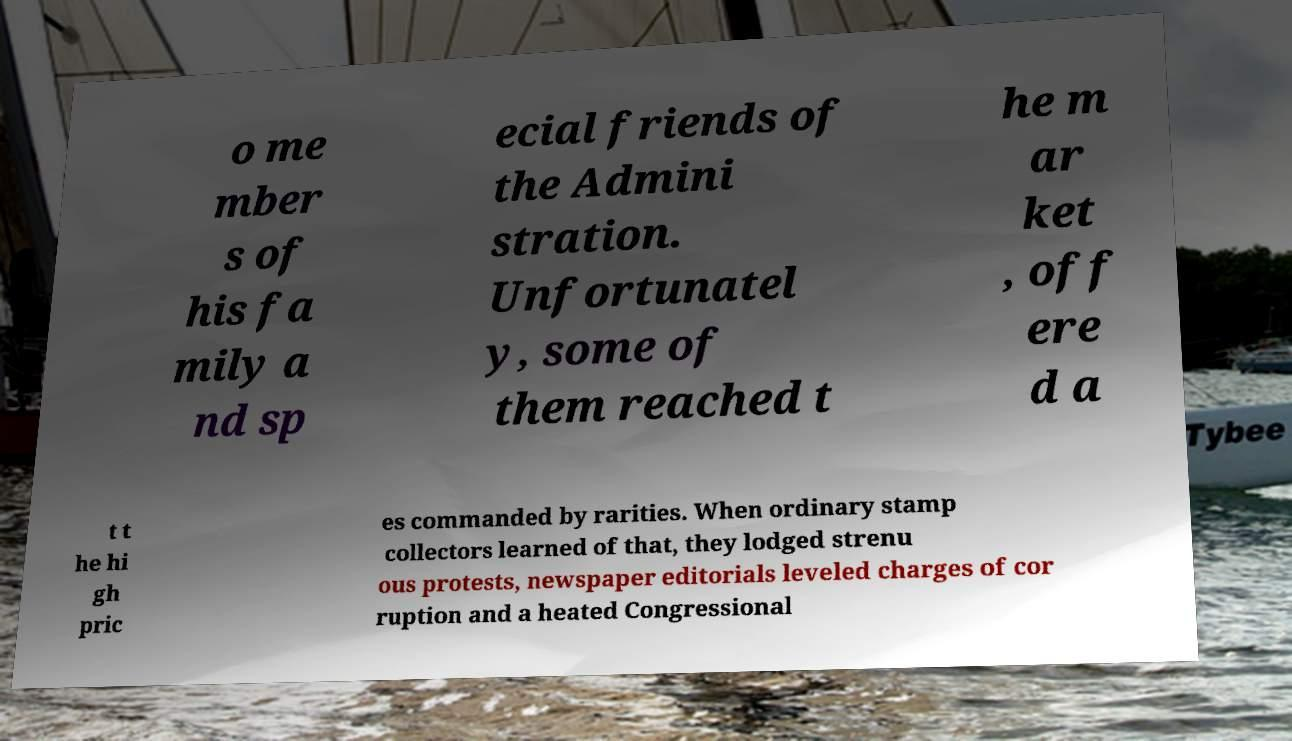Please read and relay the text visible in this image. What does it say? o me mber s of his fa mily a nd sp ecial friends of the Admini stration. Unfortunatel y, some of them reached t he m ar ket , off ere d a t t he hi gh pric es commanded by rarities. When ordinary stamp collectors learned of that, they lodged strenu ous protests, newspaper editorials leveled charges of cor ruption and a heated Congressional 